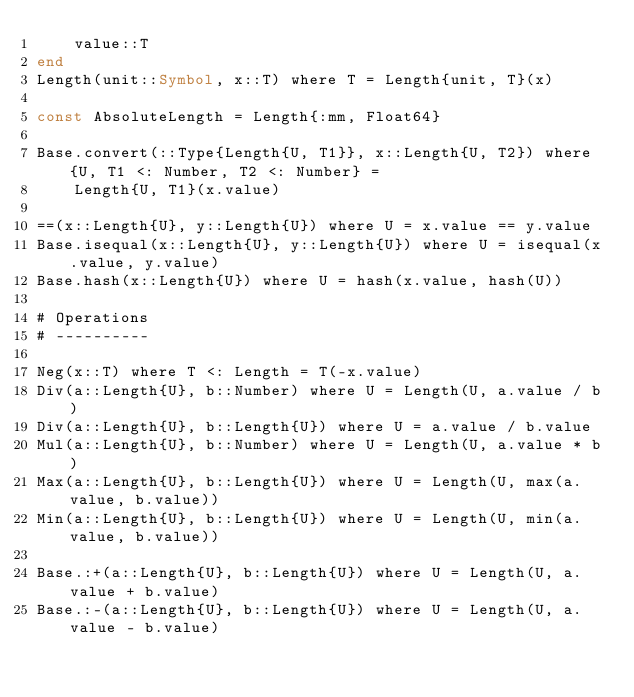Convert code to text. <code><loc_0><loc_0><loc_500><loc_500><_Julia_>    value::T
end
Length(unit::Symbol, x::T) where T = Length{unit, T}(x)

const AbsoluteLength = Length{:mm, Float64}

Base.convert(::Type{Length{U, T1}}, x::Length{U, T2}) where {U, T1 <: Number, T2 <: Number} =
    Length{U, T1}(x.value)

==(x::Length{U}, y::Length{U}) where U = x.value == y.value
Base.isequal(x::Length{U}, y::Length{U}) where U = isequal(x.value, y.value)
Base.hash(x::Length{U}) where U = hash(x.value, hash(U))

# Operations
# ----------

Neg(x::T) where T <: Length = T(-x.value)
Div(a::Length{U}, b::Number) where U = Length(U, a.value / b)
Div(a::Length{U}, b::Length{U}) where U = a.value / b.value
Mul(a::Length{U}, b::Number) where U = Length(U, a.value * b)
Max(a::Length{U}, b::Length{U}) where U = Length(U, max(a.value, b.value))
Min(a::Length{U}, b::Length{U}) where U = Length(U, min(a.value, b.value))

Base.:+(a::Length{U}, b::Length{U}) where U = Length(U, a.value + b.value)
Base.:-(a::Length{U}, b::Length{U}) where U = Length(U, a.value - b.value)
</code> 